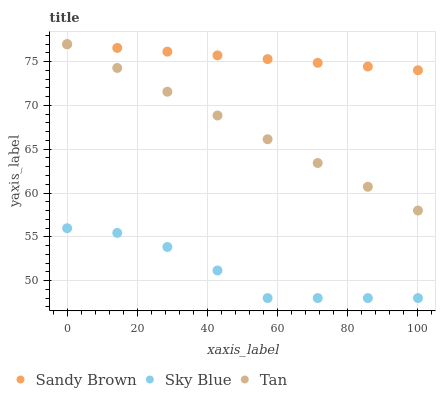Does Sky Blue have the minimum area under the curve?
Answer yes or no. Yes. Does Sandy Brown have the maximum area under the curve?
Answer yes or no. Yes. Does Tan have the minimum area under the curve?
Answer yes or no. No. Does Tan have the maximum area under the curve?
Answer yes or no. No. Is Sandy Brown the smoothest?
Answer yes or no. Yes. Is Sky Blue the roughest?
Answer yes or no. Yes. Is Tan the smoothest?
Answer yes or no. No. Is Tan the roughest?
Answer yes or no. No. Does Sky Blue have the lowest value?
Answer yes or no. Yes. Does Tan have the lowest value?
Answer yes or no. No. Does Sandy Brown have the highest value?
Answer yes or no. Yes. Is Sky Blue less than Tan?
Answer yes or no. Yes. Is Tan greater than Sky Blue?
Answer yes or no. Yes. Does Sandy Brown intersect Tan?
Answer yes or no. Yes. Is Sandy Brown less than Tan?
Answer yes or no. No. Is Sandy Brown greater than Tan?
Answer yes or no. No. Does Sky Blue intersect Tan?
Answer yes or no. No. 